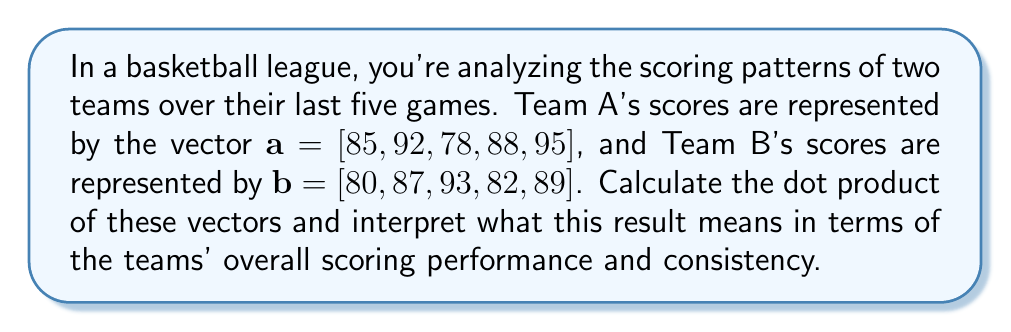Provide a solution to this math problem. To solve this problem, we'll follow these steps:

1) First, let's recall that the dot product of two vectors $\mathbf{a} = [a_1, a_2, ..., a_n]$ and $\mathbf{b} = [b_1, b_2, ..., b_n]$ is defined as:

   $$\mathbf{a} \cdot \mathbf{b} = \sum_{i=1}^n a_i b_i$$

2) In our case:
   $$\mathbf{a} = [85, 92, 78, 88, 95]$$
   $$\mathbf{b} = [80, 87, 93, 82, 89]$$

3) Let's calculate the dot product:
   $$(85 \times 80) + (92 \times 87) + (78 \times 93) + (88 \times 82) + (95 \times 89)$$

4) Multiplying each pair:
   $$6800 + 8004 + 7254 + 7216 + 8455$$

5) Summing these values:
   $$37729$$

Interpretation:
The dot product gives us a single number that represents how similar the scoring patterns of the two teams are. A higher dot product suggests more similar scoring patterns.

In this case, the dot product is quite large (37729), indicating that both teams have relatively high and similar scores across their last five games. This suggests that both teams are performing at a comparable level and are consistently scoring well.

However, to get a more accurate comparison, we would typically normalize this result by dividing by the magnitudes of the vectors. This would give us the cosine of the angle between the vectors, which is a more standardized measure of similarity.
Answer: The dot product of the two scoring vectors is 37729, indicating similar and consistently high scoring patterns for both teams over their last five games. 